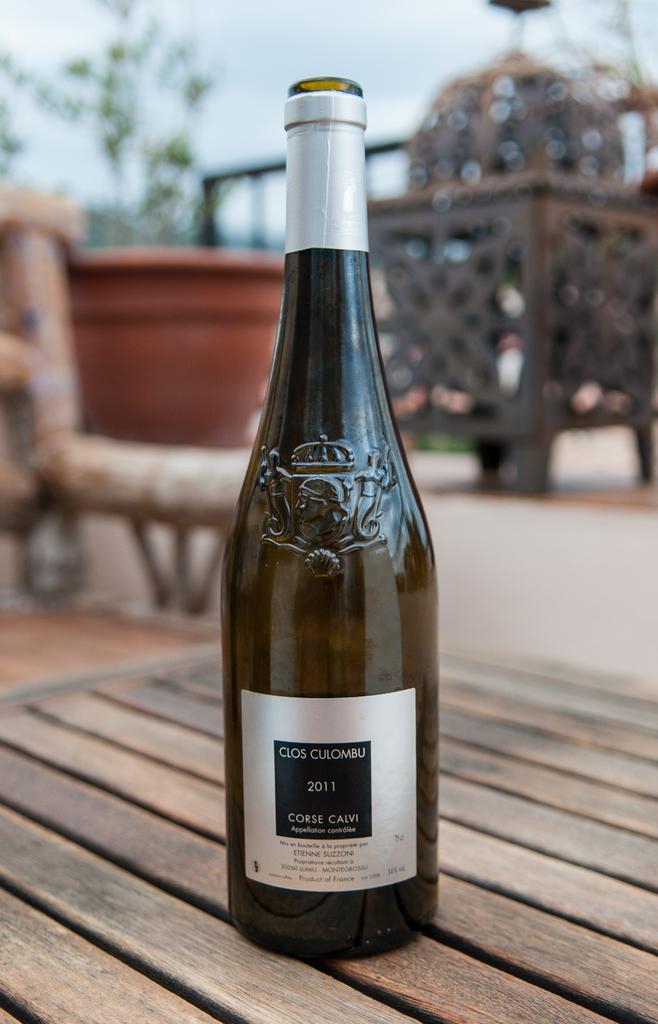What year does the bottle say it is?
Offer a terse response. 2011. What brand is this wine?
Your answer should be very brief. Clos culombu. 